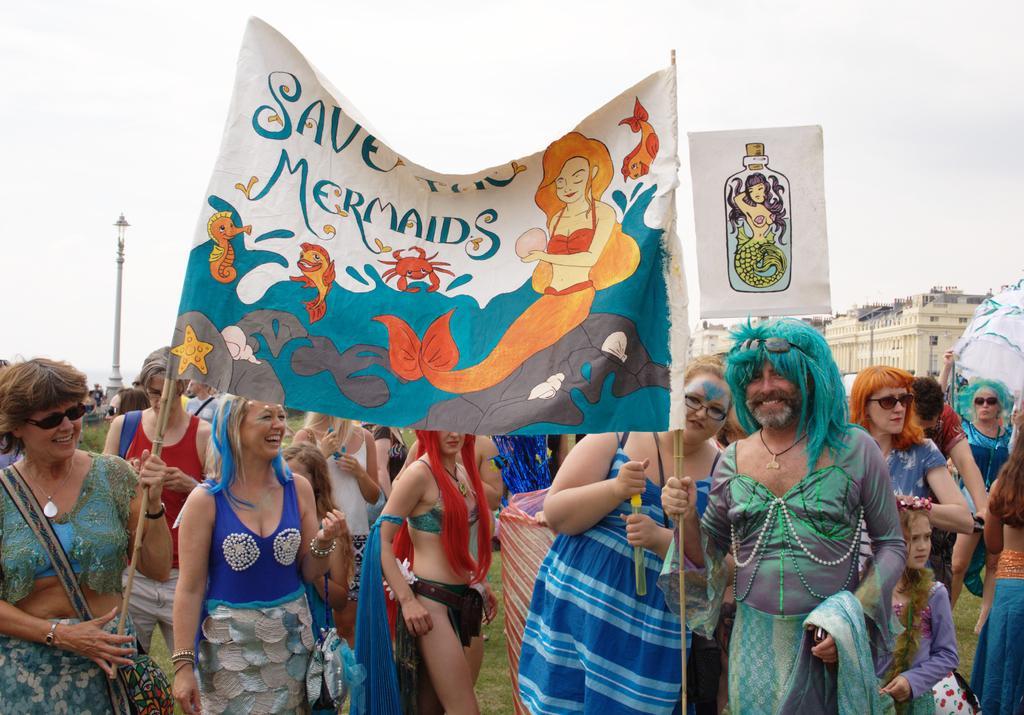How would you summarize this image in a sentence or two? In this picture I can see there are few women and a man standing on the right side, he is holding a banner, there is something written on it. There is some grass on the floor, there is a building on right side and there is a pole at left side and the sky is clear. 